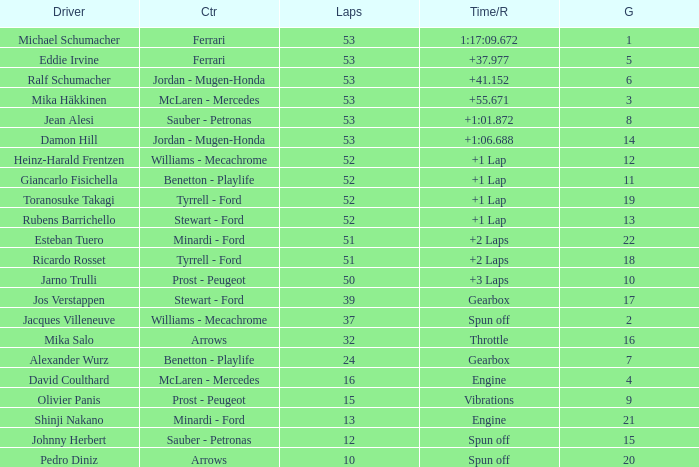What is the grid total for ralf schumacher racing over 53 laps? None. 